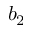<formula> <loc_0><loc_0><loc_500><loc_500>b _ { 2 }</formula> 